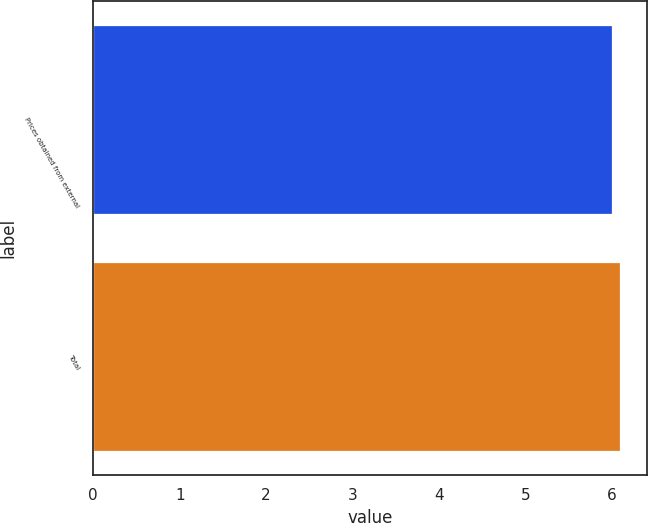Convert chart to OTSL. <chart><loc_0><loc_0><loc_500><loc_500><bar_chart><fcel>Prices obtained from external<fcel>Total<nl><fcel>6<fcel>6.1<nl></chart> 